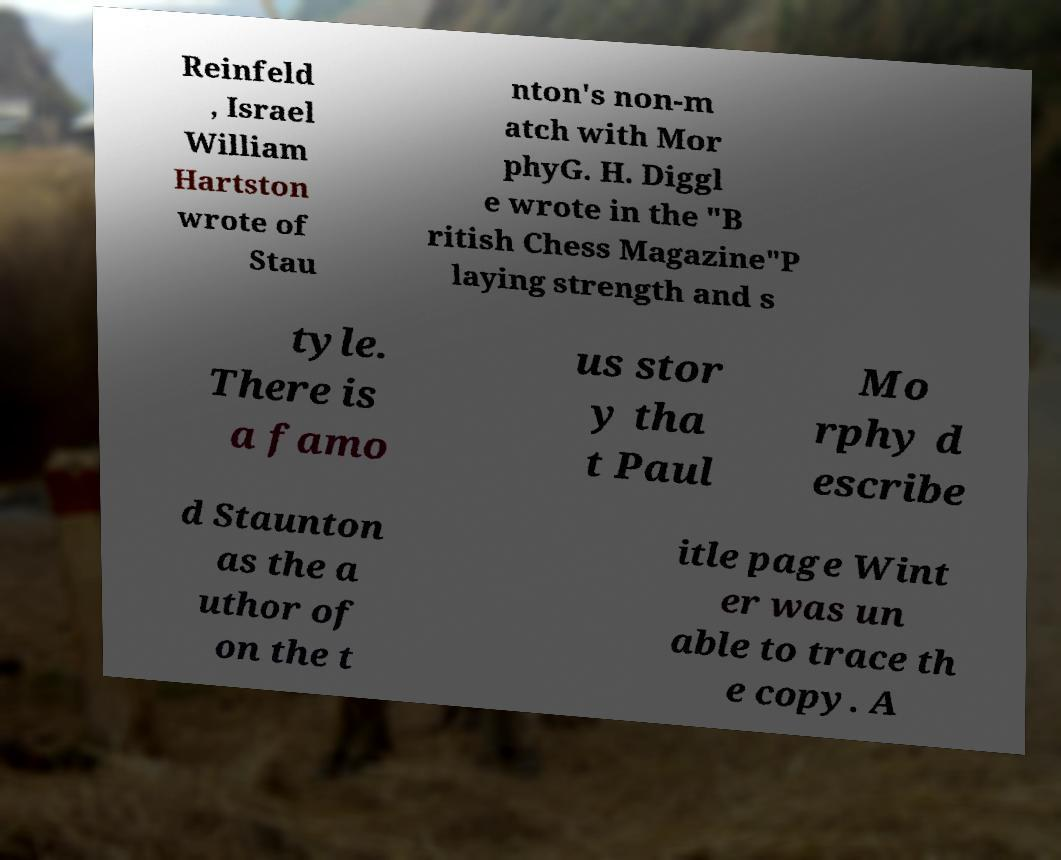I need the written content from this picture converted into text. Can you do that? Reinfeld , Israel William Hartston wrote of Stau nton's non-m atch with Mor phyG. H. Diggl e wrote in the "B ritish Chess Magazine"P laying strength and s tyle. There is a famo us stor y tha t Paul Mo rphy d escribe d Staunton as the a uthor of on the t itle page Wint er was un able to trace th e copy. A 